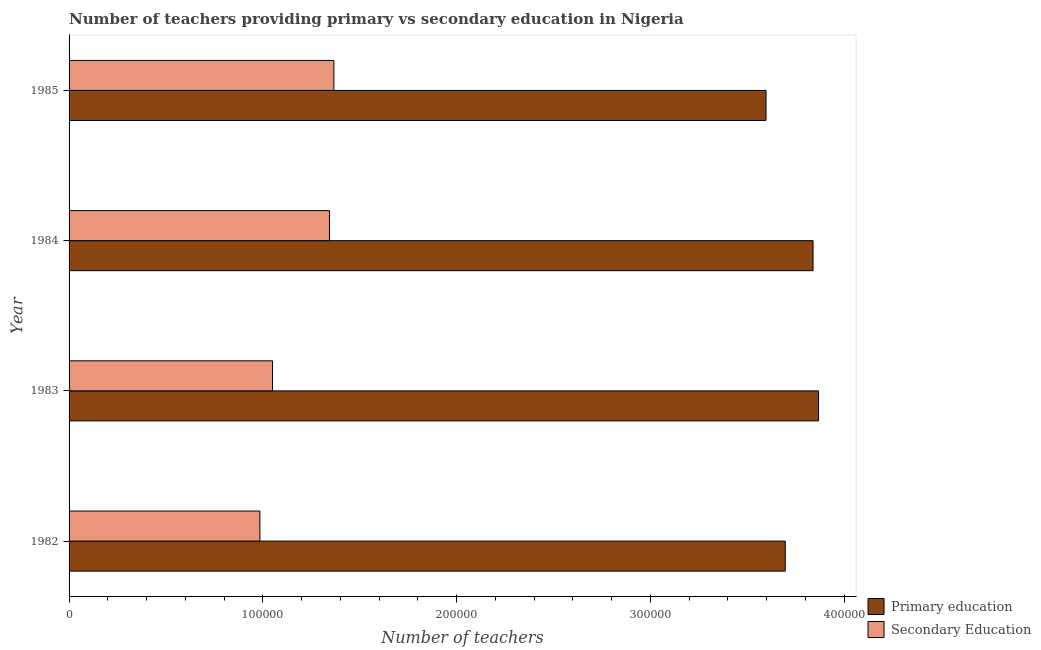How many different coloured bars are there?
Your response must be concise. 2. How many groups of bars are there?
Keep it short and to the point. 4. Are the number of bars per tick equal to the number of legend labels?
Your answer should be compact. Yes. What is the label of the 2nd group of bars from the top?
Make the answer very short. 1984. In how many cases, is the number of bars for a given year not equal to the number of legend labels?
Your answer should be very brief. 0. What is the number of primary teachers in 1982?
Give a very brief answer. 3.70e+05. Across all years, what is the maximum number of secondary teachers?
Your answer should be very brief. 1.37e+05. Across all years, what is the minimum number of primary teachers?
Ensure brevity in your answer.  3.60e+05. In which year was the number of primary teachers maximum?
Make the answer very short. 1983. What is the total number of secondary teachers in the graph?
Your answer should be very brief. 4.75e+05. What is the difference between the number of secondary teachers in 1983 and that in 1984?
Your answer should be very brief. -2.94e+04. What is the difference between the number of primary teachers in 1984 and the number of secondary teachers in 1983?
Your answer should be very brief. 2.79e+05. What is the average number of primary teachers per year?
Provide a short and direct response. 3.75e+05. In the year 1985, what is the difference between the number of primary teachers and number of secondary teachers?
Ensure brevity in your answer.  2.23e+05. Is the number of primary teachers in 1984 less than that in 1985?
Provide a succinct answer. No. Is the difference between the number of primary teachers in 1983 and 1985 greater than the difference between the number of secondary teachers in 1983 and 1985?
Your answer should be very brief. Yes. What is the difference between the highest and the second highest number of secondary teachers?
Give a very brief answer. 2277. What is the difference between the highest and the lowest number of secondary teachers?
Offer a terse response. 3.82e+04. In how many years, is the number of secondary teachers greater than the average number of secondary teachers taken over all years?
Ensure brevity in your answer.  2. What does the 1st bar from the top in 1982 represents?
Your response must be concise. Secondary Education. What does the 2nd bar from the bottom in 1983 represents?
Give a very brief answer. Secondary Education. Are all the bars in the graph horizontal?
Offer a very short reply. Yes. Does the graph contain any zero values?
Provide a short and direct response. No. Does the graph contain grids?
Provide a short and direct response. No. Where does the legend appear in the graph?
Make the answer very short. Bottom right. How many legend labels are there?
Provide a succinct answer. 2. What is the title of the graph?
Keep it short and to the point. Number of teachers providing primary vs secondary education in Nigeria. What is the label or title of the X-axis?
Keep it short and to the point. Number of teachers. What is the label or title of the Y-axis?
Offer a terse response. Year. What is the Number of teachers of Primary education in 1982?
Provide a succinct answer. 3.70e+05. What is the Number of teachers of Secondary Education in 1982?
Your answer should be compact. 9.85e+04. What is the Number of teachers in Primary education in 1983?
Your response must be concise. 3.87e+05. What is the Number of teachers of Secondary Education in 1983?
Offer a terse response. 1.05e+05. What is the Number of teachers of Primary education in 1984?
Give a very brief answer. 3.84e+05. What is the Number of teachers in Secondary Education in 1984?
Your answer should be very brief. 1.34e+05. What is the Number of teachers of Primary education in 1985?
Offer a very short reply. 3.60e+05. What is the Number of teachers of Secondary Education in 1985?
Your response must be concise. 1.37e+05. Across all years, what is the maximum Number of teachers of Primary education?
Give a very brief answer. 3.87e+05. Across all years, what is the maximum Number of teachers in Secondary Education?
Ensure brevity in your answer.  1.37e+05. Across all years, what is the minimum Number of teachers of Primary education?
Your answer should be compact. 3.60e+05. Across all years, what is the minimum Number of teachers of Secondary Education?
Make the answer very short. 9.85e+04. What is the total Number of teachers in Primary education in the graph?
Make the answer very short. 1.50e+06. What is the total Number of teachers in Secondary Education in the graph?
Your response must be concise. 4.75e+05. What is the difference between the Number of teachers in Primary education in 1982 and that in 1983?
Your answer should be compact. -1.72e+04. What is the difference between the Number of teachers in Secondary Education in 1982 and that in 1983?
Provide a succinct answer. -6516. What is the difference between the Number of teachers of Primary education in 1982 and that in 1984?
Your answer should be very brief. -1.44e+04. What is the difference between the Number of teachers of Secondary Education in 1982 and that in 1984?
Offer a terse response. -3.59e+04. What is the difference between the Number of teachers of Primary education in 1982 and that in 1985?
Offer a terse response. 9935. What is the difference between the Number of teachers of Secondary Education in 1982 and that in 1985?
Ensure brevity in your answer.  -3.82e+04. What is the difference between the Number of teachers in Primary education in 1983 and that in 1984?
Keep it short and to the point. 2837. What is the difference between the Number of teachers of Secondary Education in 1983 and that in 1984?
Offer a very short reply. -2.94e+04. What is the difference between the Number of teachers of Primary education in 1983 and that in 1985?
Keep it short and to the point. 2.71e+04. What is the difference between the Number of teachers of Secondary Education in 1983 and that in 1985?
Keep it short and to the point. -3.17e+04. What is the difference between the Number of teachers in Primary education in 1984 and that in 1985?
Your response must be concise. 2.43e+04. What is the difference between the Number of teachers in Secondary Education in 1984 and that in 1985?
Provide a short and direct response. -2277. What is the difference between the Number of teachers in Primary education in 1982 and the Number of teachers in Secondary Education in 1983?
Your response must be concise. 2.65e+05. What is the difference between the Number of teachers in Primary education in 1982 and the Number of teachers in Secondary Education in 1984?
Your answer should be very brief. 2.35e+05. What is the difference between the Number of teachers in Primary education in 1982 and the Number of teachers in Secondary Education in 1985?
Your answer should be very brief. 2.33e+05. What is the difference between the Number of teachers in Primary education in 1983 and the Number of teachers in Secondary Education in 1984?
Give a very brief answer. 2.52e+05. What is the difference between the Number of teachers in Primary education in 1983 and the Number of teachers in Secondary Education in 1985?
Make the answer very short. 2.50e+05. What is the difference between the Number of teachers of Primary education in 1984 and the Number of teachers of Secondary Education in 1985?
Ensure brevity in your answer.  2.47e+05. What is the average Number of teachers in Primary education per year?
Offer a very short reply. 3.75e+05. What is the average Number of teachers of Secondary Education per year?
Your answer should be very brief. 1.19e+05. In the year 1982, what is the difference between the Number of teachers in Primary education and Number of teachers in Secondary Education?
Offer a terse response. 2.71e+05. In the year 1983, what is the difference between the Number of teachers of Primary education and Number of teachers of Secondary Education?
Provide a short and direct response. 2.82e+05. In the year 1984, what is the difference between the Number of teachers of Primary education and Number of teachers of Secondary Education?
Your response must be concise. 2.50e+05. In the year 1985, what is the difference between the Number of teachers in Primary education and Number of teachers in Secondary Education?
Make the answer very short. 2.23e+05. What is the ratio of the Number of teachers in Primary education in 1982 to that in 1983?
Make the answer very short. 0.96. What is the ratio of the Number of teachers in Secondary Education in 1982 to that in 1983?
Offer a very short reply. 0.94. What is the ratio of the Number of teachers of Primary education in 1982 to that in 1984?
Your answer should be very brief. 0.96. What is the ratio of the Number of teachers of Secondary Education in 1982 to that in 1984?
Your answer should be compact. 0.73. What is the ratio of the Number of teachers of Primary education in 1982 to that in 1985?
Give a very brief answer. 1.03. What is the ratio of the Number of teachers in Secondary Education in 1982 to that in 1985?
Provide a short and direct response. 0.72. What is the ratio of the Number of teachers of Primary education in 1983 to that in 1984?
Offer a very short reply. 1.01. What is the ratio of the Number of teachers in Secondary Education in 1983 to that in 1984?
Ensure brevity in your answer.  0.78. What is the ratio of the Number of teachers of Primary education in 1983 to that in 1985?
Keep it short and to the point. 1.08. What is the ratio of the Number of teachers of Secondary Education in 1983 to that in 1985?
Make the answer very short. 0.77. What is the ratio of the Number of teachers of Primary education in 1984 to that in 1985?
Give a very brief answer. 1.07. What is the ratio of the Number of teachers of Secondary Education in 1984 to that in 1985?
Provide a succinct answer. 0.98. What is the difference between the highest and the second highest Number of teachers in Primary education?
Your answer should be very brief. 2837. What is the difference between the highest and the second highest Number of teachers of Secondary Education?
Give a very brief answer. 2277. What is the difference between the highest and the lowest Number of teachers in Primary education?
Provide a short and direct response. 2.71e+04. What is the difference between the highest and the lowest Number of teachers in Secondary Education?
Your response must be concise. 3.82e+04. 